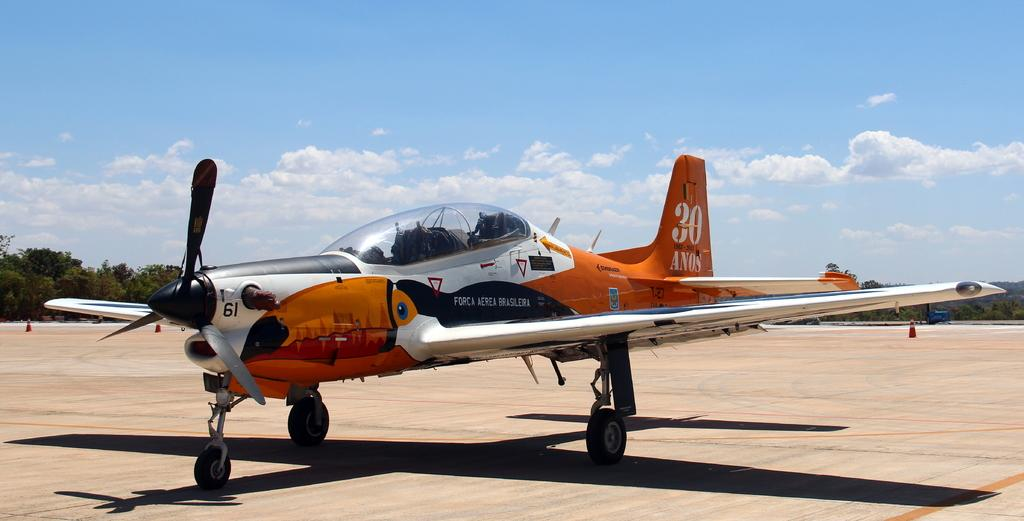What is the main subject in the front portion of the image? There is a plane in the front portion of the image. What can be observed about the plane's position in relation to the ground? The plane's shadow is visible on the ground. How would you describe the weather conditions in the image? The background of the image includes a cloudy sky. What type of vegetation is visible in the background of the image? There are trees in the background of the image. What safety equipment is present in the background of the image? Traffic cones are present in the background of the image. What type of wool is being used to knit a pocket in the image? There is no wool or knitting activity present in the image. Can you describe the teeth of the person sitting in the plane in the image? There are no people visible in the image, let alone someone sitting in the plane. 